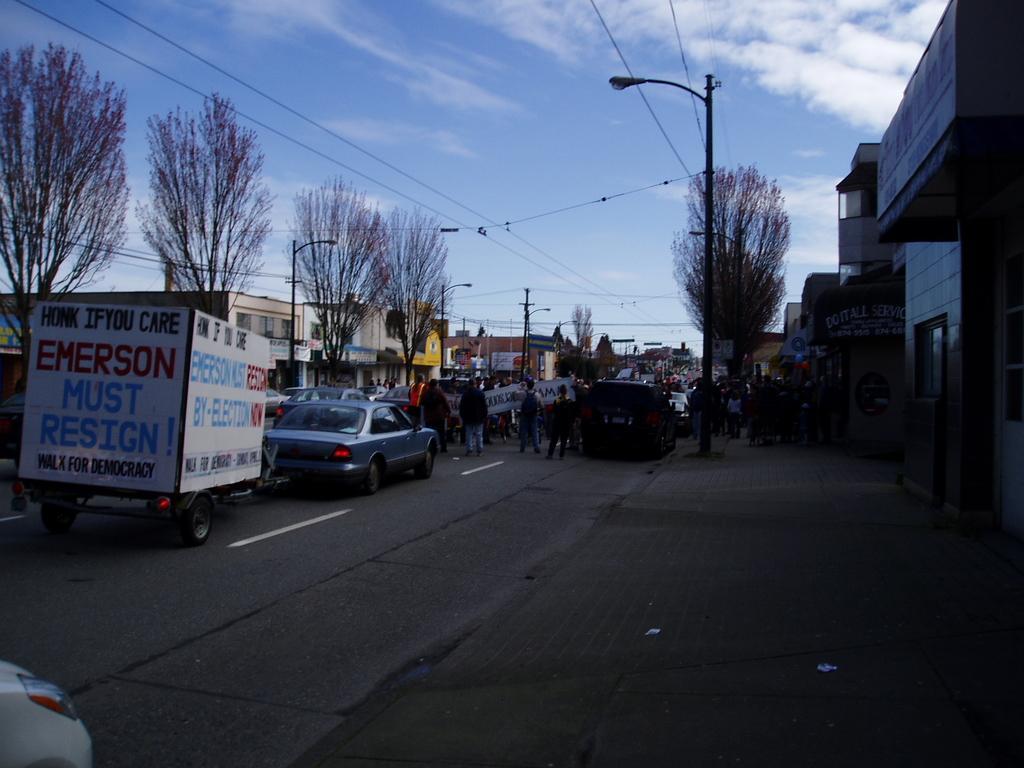How would you summarize this image in a sentence or two? In this image we can see motor vehicles on the road, people standing on the road and holding advertisements in their hands, street poles, street lights, electric poles, electric cables, buildings, name boards, trees and sky with clouds. 